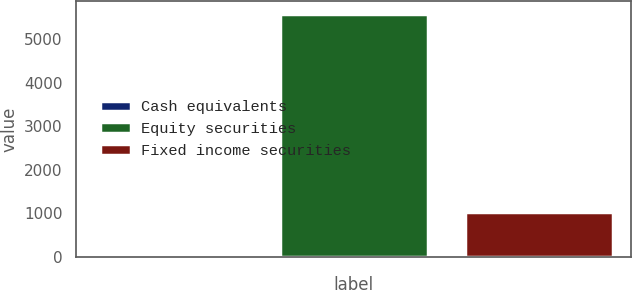<chart> <loc_0><loc_0><loc_500><loc_500><bar_chart><fcel>Cash equivalents<fcel>Equity securities<fcel>Fixed income securities<nl><fcel>20<fcel>5595<fcel>1040<nl></chart> 